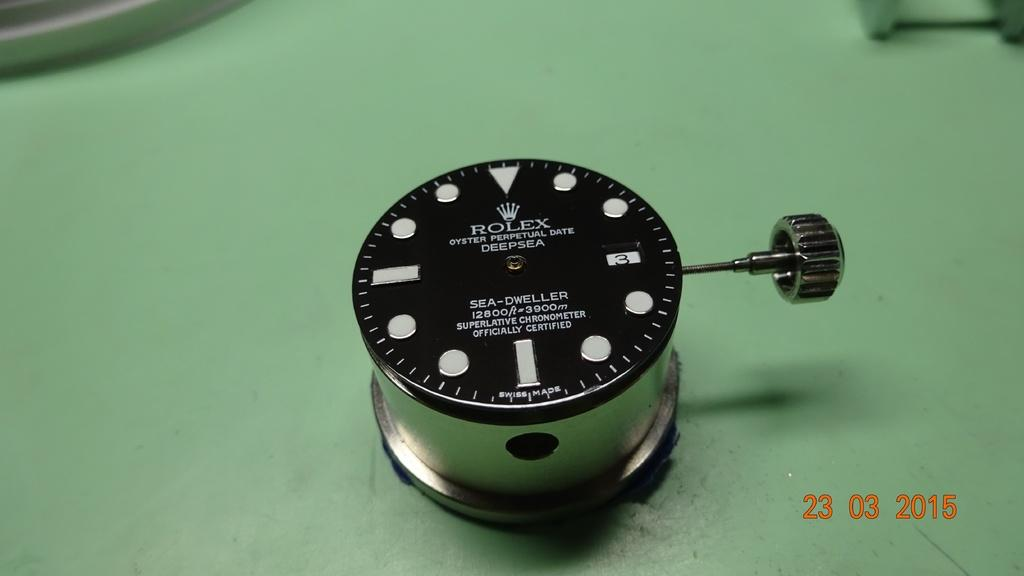Provide a one-sentence caption for the provided image. Face of a watch which has the word ROLEX in all white letters. 